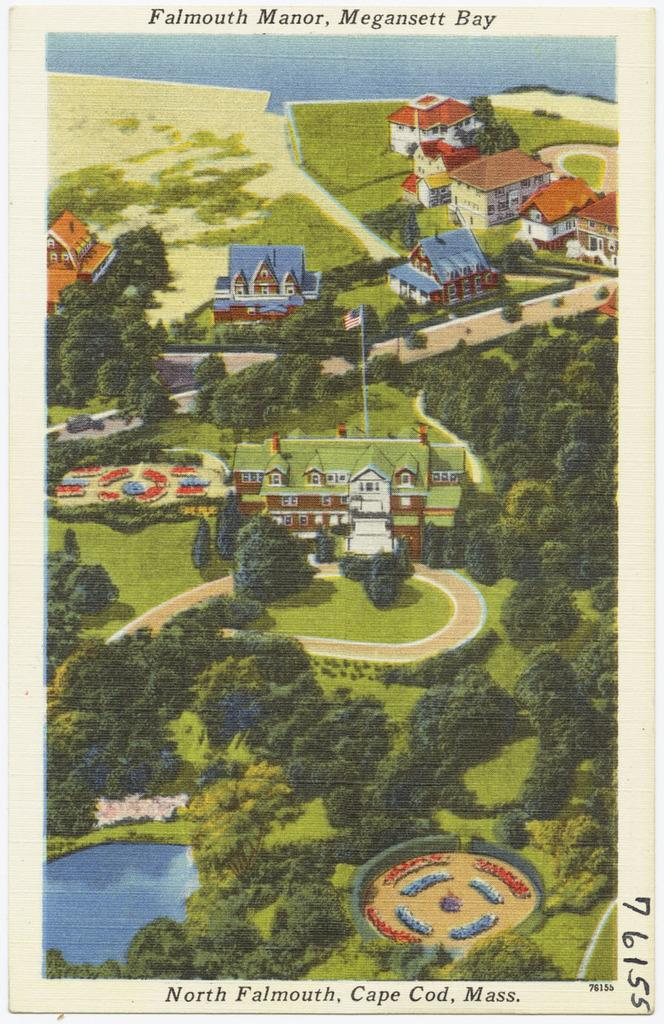<image>
Render a clear and concise summary of the photo. A picture of Falmouth Manor, Magansett Bay, withe the number 76155 on a side. 